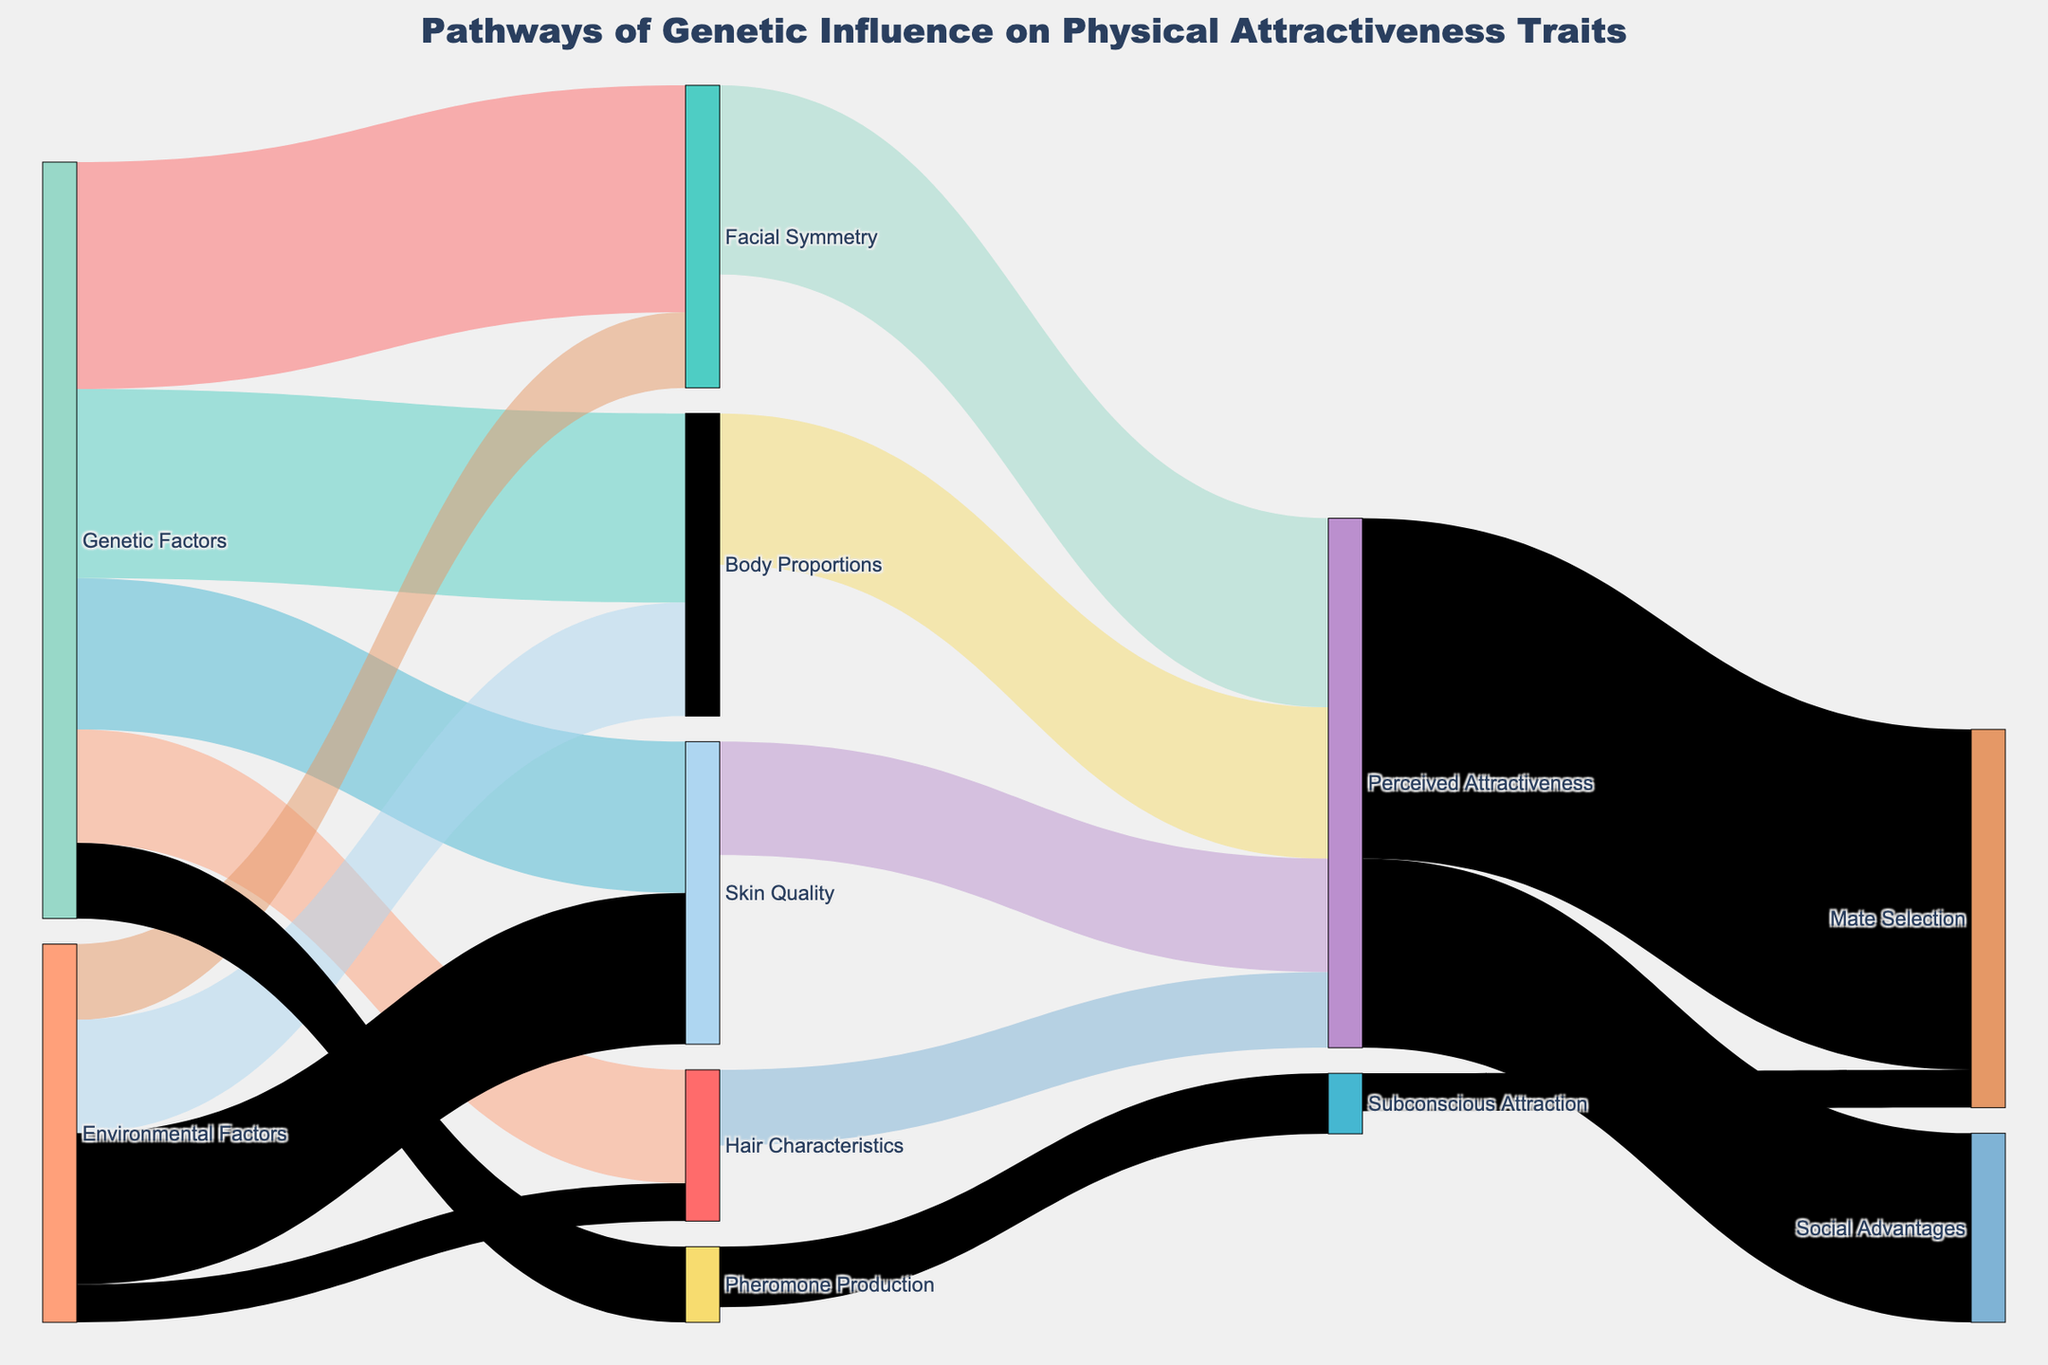What is the main title of the Sankey diagram? The main title is typically displayed at the top of the diagram and summarizes the content or purpose of the figure.
Answer: Pathways of Genetic Influence on Physical Attractiveness Traits How many pathways are there from "Genetic Factors" to the intermediate traits? Count the links originating from "Genetic Factors" to any intermediate nodes like "Facial Symmetry," "Body Proportions," "Skin Quality," and "Hair Characteristics."
Answer: 4 Which trait from "Genetic Factors" contributes the most to "Perceived Attractiveness"? Identify the trait linked to "Perceived Attractiveness" with the highest value. Compare the values indicated.
Answer: Facial Symmetry What is the total value flowing into "Mate Selection"? Sum the input values flowing into "Mate Selection," including from "Perceived Attractiveness" and "Subconscious Attraction."
Answer: 50 Which factors influence "Facial Symmetry"? Identify the sources linked to "Facial Symmetry."
Answer: Genetic Factors, Environmental Factors Is "Hair Characteristics" more influenced by "Genetic Factors" or "Environmental Factors"? Compare the provided values that link "Hair Characteristics" to both "Genetic Factors" and "Environmental Factors."
Answer: Genetic Factors How do "environmental factors" affect physical attractiveness traits compared to "genetic factors"? Sum the values from "Environmental Factors" to all traits and compare with the sum from "Genetic Factors" to those same traits.
Answer: Environmental: 50; Genetic: 90 What is the smallest value in the entire Sankey diagram? Identify the smallest numerical value mentioned in the dataset.
Answer: 5 Which intermediate trait has the least influence on "Perceived Attractiveness"? Compare the values tied to "Perceived Attractiveness" from intermediate traits like "Facial Symmetry," "Body Proportions," etc.
Answer: Hair Characteristics 